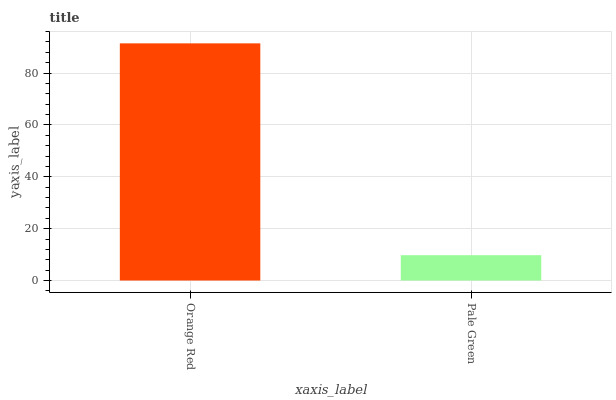Is Pale Green the maximum?
Answer yes or no. No. Is Orange Red greater than Pale Green?
Answer yes or no. Yes. Is Pale Green less than Orange Red?
Answer yes or no. Yes. Is Pale Green greater than Orange Red?
Answer yes or no. No. Is Orange Red less than Pale Green?
Answer yes or no. No. Is Orange Red the high median?
Answer yes or no. Yes. Is Pale Green the low median?
Answer yes or no. Yes. Is Pale Green the high median?
Answer yes or no. No. Is Orange Red the low median?
Answer yes or no. No. 